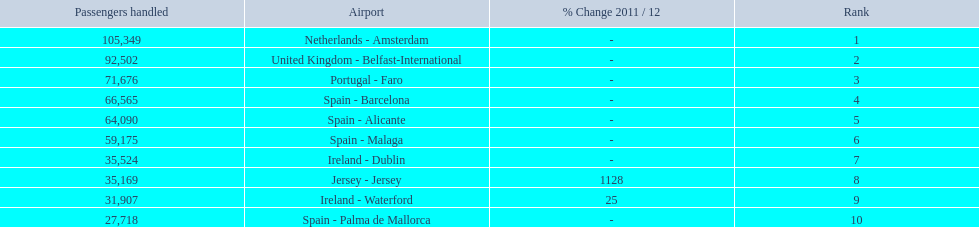Can you give me this table as a dict? {'header': ['Passengers handled', 'Airport', '% Change 2011 / 12', 'Rank'], 'rows': [['105,349', 'Netherlands - Amsterdam', '-', '1'], ['92,502', 'United Kingdom - Belfast-International', '-', '2'], ['71,676', 'Portugal - Faro', '-', '3'], ['66,565', 'Spain - Barcelona', '-', '4'], ['64,090', 'Spain - Alicante', '-', '5'], ['59,175', 'Spain - Malaga', '-', '6'], ['35,524', 'Ireland - Dublin', '-', '7'], ['35,169', 'Jersey - Jersey', '1128', '8'], ['31,907', 'Ireland - Waterford', '25', '9'], ['27,718', 'Spain - Palma de Mallorca', '-', '10']]} What are the names of all the airports? Netherlands - Amsterdam, United Kingdom - Belfast-International, Portugal - Faro, Spain - Barcelona, Spain - Alicante, Spain - Malaga, Ireland - Dublin, Jersey - Jersey, Ireland - Waterford, Spain - Palma de Mallorca. Of these, what are all the passenger counts? 105,349, 92,502, 71,676, 66,565, 64,090, 59,175, 35,524, 35,169, 31,907, 27,718. Of these, which airport had more passengers than the united kingdom? Netherlands - Amsterdam. 